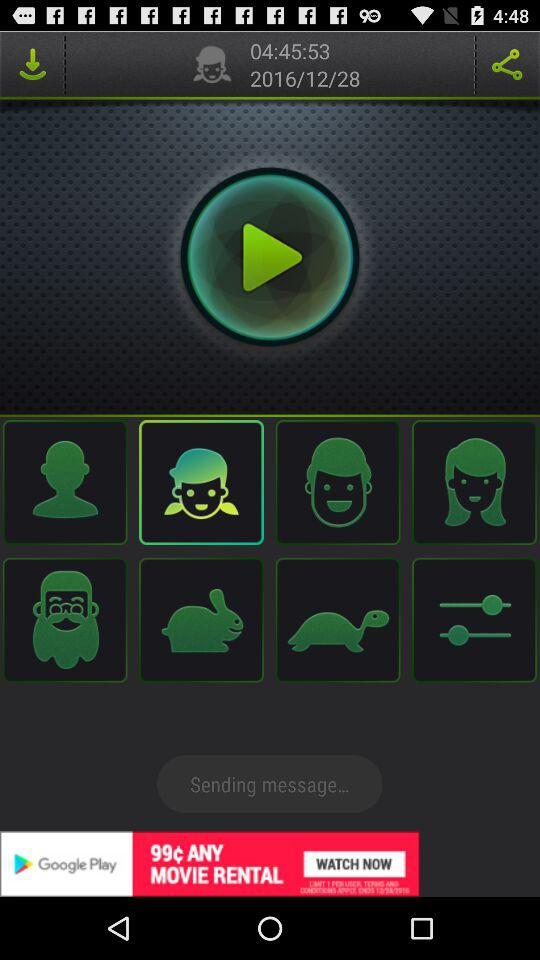What is the mentioned date? The mentioned date is December 28, 2016. 